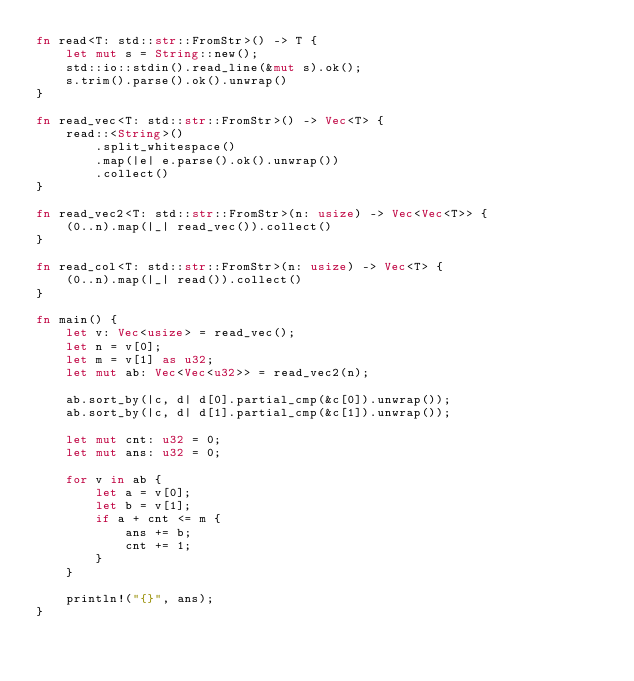Convert code to text. <code><loc_0><loc_0><loc_500><loc_500><_Rust_>fn read<T: std::str::FromStr>() -> T {
    let mut s = String::new();
    std::io::stdin().read_line(&mut s).ok();
    s.trim().parse().ok().unwrap()
}

fn read_vec<T: std::str::FromStr>() -> Vec<T> {
    read::<String>()
        .split_whitespace()
        .map(|e| e.parse().ok().unwrap())
        .collect()
}

fn read_vec2<T: std::str::FromStr>(n: usize) -> Vec<Vec<T>> {
    (0..n).map(|_| read_vec()).collect()
}

fn read_col<T: std::str::FromStr>(n: usize) -> Vec<T> {
    (0..n).map(|_| read()).collect()
}

fn main() {
    let v: Vec<usize> = read_vec();
    let n = v[0];
    let m = v[1] as u32;
    let mut ab: Vec<Vec<u32>> = read_vec2(n);

    ab.sort_by(|c, d| d[0].partial_cmp(&c[0]).unwrap());
    ab.sort_by(|c, d| d[1].partial_cmp(&c[1]).unwrap());

    let mut cnt: u32 = 0;
    let mut ans: u32 = 0;

    for v in ab {
        let a = v[0];
        let b = v[1];
        if a + cnt <= m {
            ans += b;
            cnt += 1;
        }
    }

    println!("{}", ans);
}
</code> 